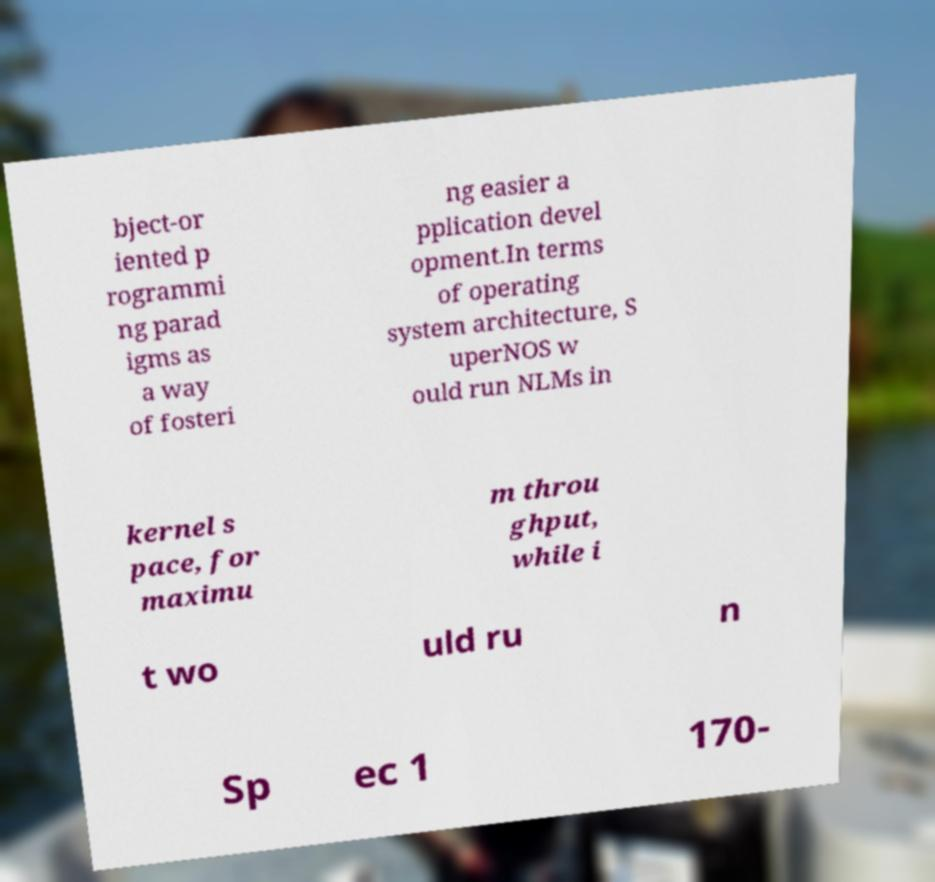Can you accurately transcribe the text from the provided image for me? bject-or iented p rogrammi ng parad igms as a way of fosteri ng easier a pplication devel opment.In terms of operating system architecture, S uperNOS w ould run NLMs in kernel s pace, for maximu m throu ghput, while i t wo uld ru n Sp ec 1 170- 